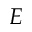<formula> <loc_0><loc_0><loc_500><loc_500>E</formula> 